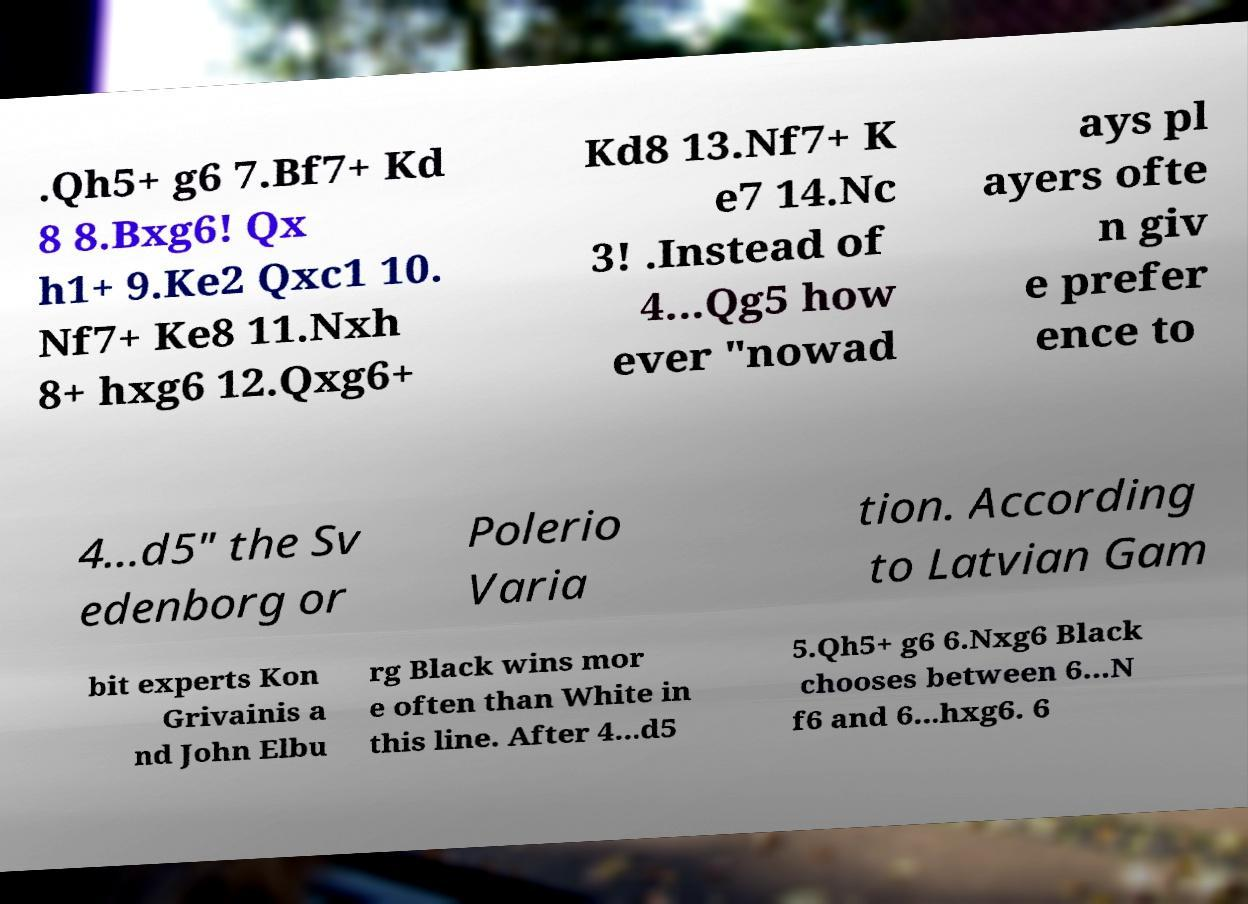Could you assist in decoding the text presented in this image and type it out clearly? .Qh5+ g6 7.Bf7+ Kd 8 8.Bxg6! Qx h1+ 9.Ke2 Qxc1 10. Nf7+ Ke8 11.Nxh 8+ hxg6 12.Qxg6+ Kd8 13.Nf7+ K e7 14.Nc 3! .Instead of 4...Qg5 how ever "nowad ays pl ayers ofte n giv e prefer ence to 4...d5" the Sv edenborg or Polerio Varia tion. According to Latvian Gam bit experts Kon Grivainis a nd John Elbu rg Black wins mor e often than White in this line. After 4...d5 5.Qh5+ g6 6.Nxg6 Black chooses between 6...N f6 and 6...hxg6. 6 